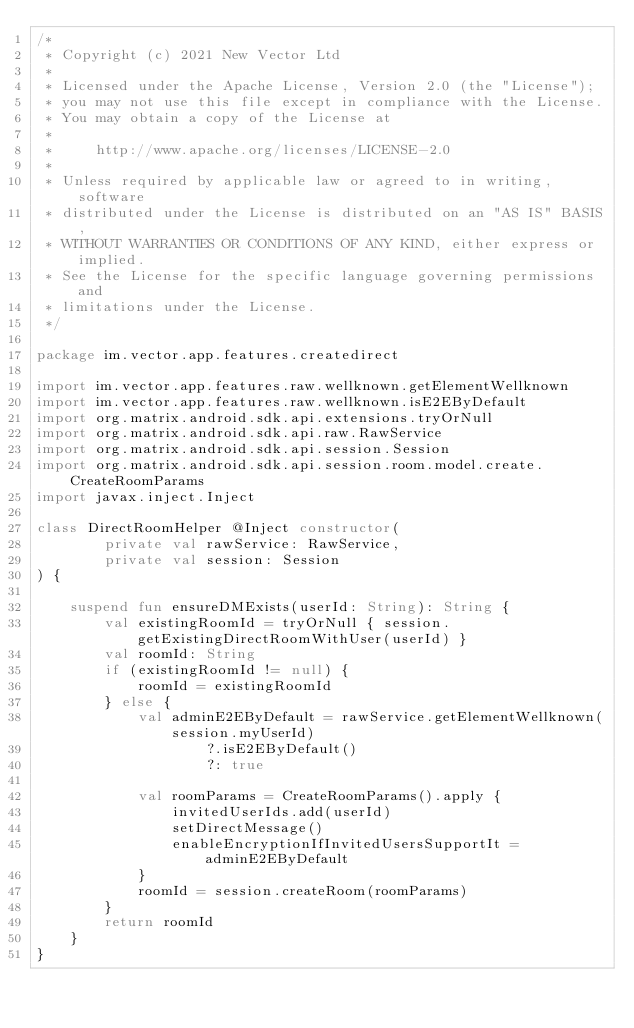Convert code to text. <code><loc_0><loc_0><loc_500><loc_500><_Kotlin_>/*
 * Copyright (c) 2021 New Vector Ltd
 *
 * Licensed under the Apache License, Version 2.0 (the "License");
 * you may not use this file except in compliance with the License.
 * You may obtain a copy of the License at
 *
 *     http://www.apache.org/licenses/LICENSE-2.0
 *
 * Unless required by applicable law or agreed to in writing, software
 * distributed under the License is distributed on an "AS IS" BASIS,
 * WITHOUT WARRANTIES OR CONDITIONS OF ANY KIND, either express or implied.
 * See the License for the specific language governing permissions and
 * limitations under the License.
 */

package im.vector.app.features.createdirect

import im.vector.app.features.raw.wellknown.getElementWellknown
import im.vector.app.features.raw.wellknown.isE2EByDefault
import org.matrix.android.sdk.api.extensions.tryOrNull
import org.matrix.android.sdk.api.raw.RawService
import org.matrix.android.sdk.api.session.Session
import org.matrix.android.sdk.api.session.room.model.create.CreateRoomParams
import javax.inject.Inject

class DirectRoomHelper @Inject constructor(
        private val rawService: RawService,
        private val session: Session
) {

    suspend fun ensureDMExists(userId: String): String {
        val existingRoomId = tryOrNull { session.getExistingDirectRoomWithUser(userId) }
        val roomId: String
        if (existingRoomId != null) {
            roomId = existingRoomId
        } else {
            val adminE2EByDefault = rawService.getElementWellknown(session.myUserId)
                    ?.isE2EByDefault()
                    ?: true

            val roomParams = CreateRoomParams().apply {
                invitedUserIds.add(userId)
                setDirectMessage()
                enableEncryptionIfInvitedUsersSupportIt = adminE2EByDefault
            }
            roomId = session.createRoom(roomParams)
        }
        return roomId
    }
}
</code> 